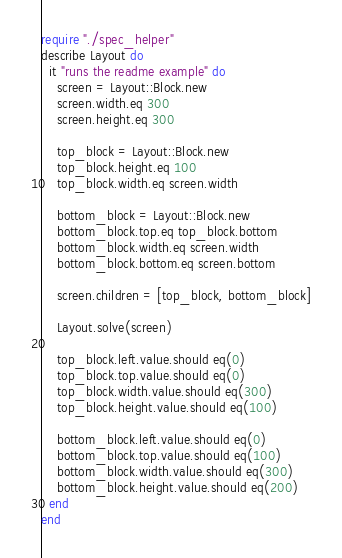Convert code to text. <code><loc_0><loc_0><loc_500><loc_500><_Crystal_>require "./spec_helper"
describe Layout do
  it "runs the readme example" do
    screen = Layout::Block.new
    screen.width.eq 300
    screen.height.eq 300

    top_block = Layout::Block.new
    top_block.height.eq 100
    top_block.width.eq screen.width

    bottom_block = Layout::Block.new
    bottom_block.top.eq top_block.bottom
    bottom_block.width.eq screen.width
    bottom_block.bottom.eq screen.bottom

    screen.children = [top_block, bottom_block]

    Layout.solve(screen)

    top_block.left.value.should eq(0)
    top_block.top.value.should eq(0)
    top_block.width.value.should eq(300)
    top_block.height.value.should eq(100)

    bottom_block.left.value.should eq(0)
    bottom_block.top.value.should eq(100)
    bottom_block.width.value.should eq(300)
    bottom_block.height.value.should eq(200)
  end
end
</code> 